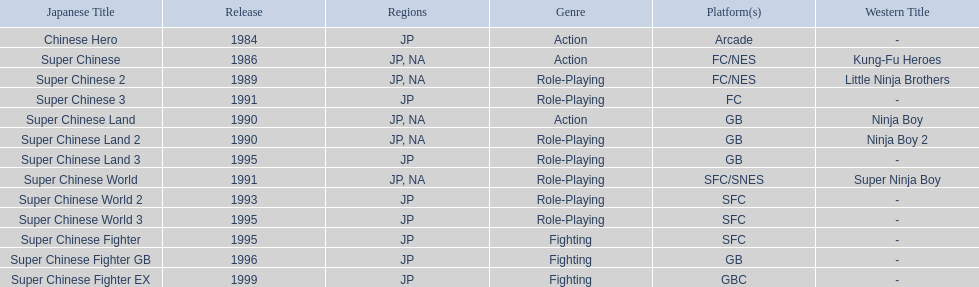What japanese titles were released in the north american (na) region? Super Chinese, Super Chinese 2, Super Chinese Land, Super Chinese Land 2, Super Chinese World. Of those, which one was released most recently? Super Chinese World. 